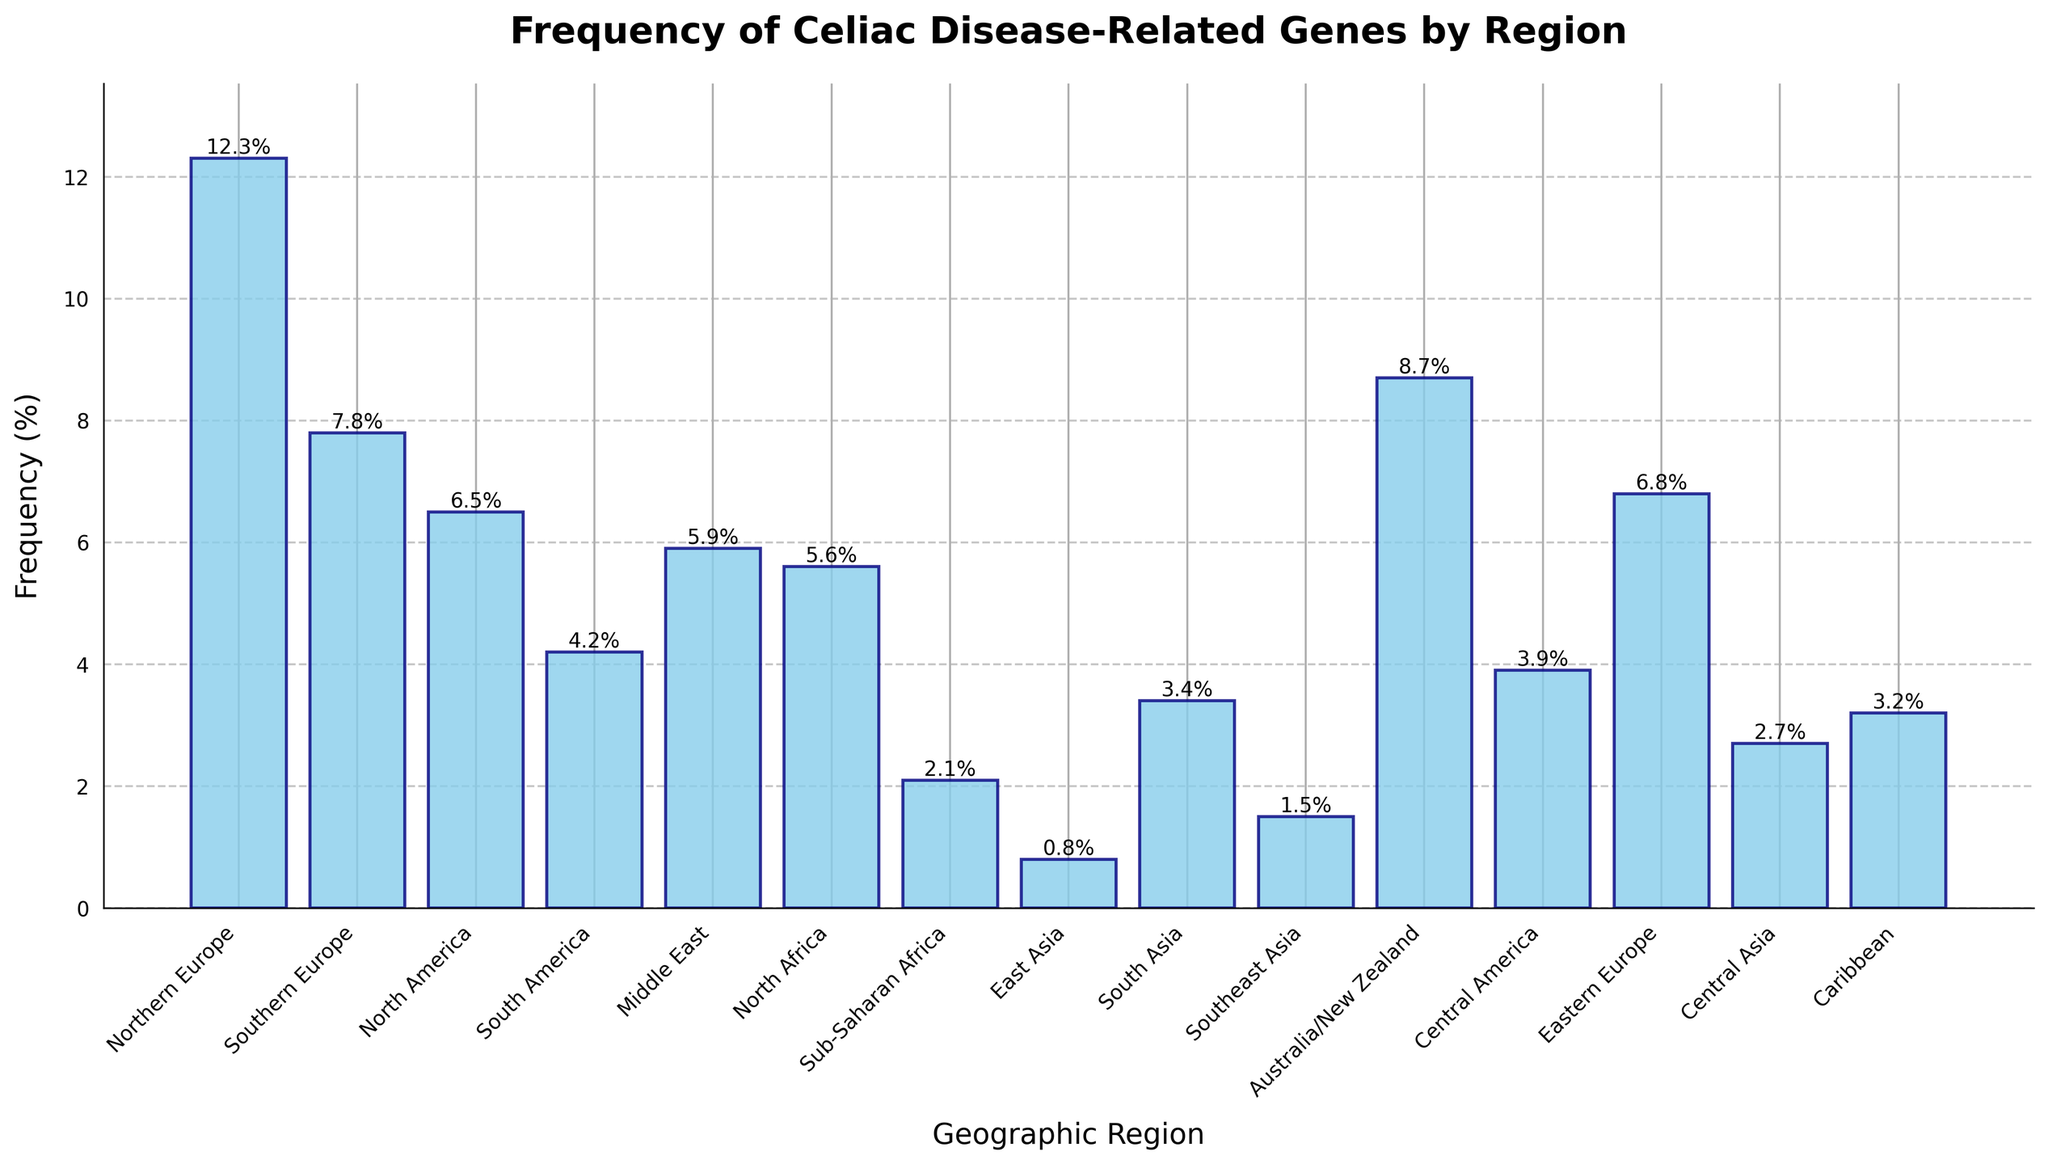Which region shows the highest frequency of celiac disease-related genes? To find this, look at the bar with the greatest height. Northern Europe has the highest bar with a frequency of 12.3%.
Answer: Northern Europe Which region shows the lowest frequency of celiac disease-related genes? To determine the lowest frequency, look at the shortest bar. East Asia has the shortest bar with a frequency of 0.8%.
Answer: East Asia What is the difference in frequency between Northern Europe and East Asia? Find the frequencies for Northern Europe (12.3%) and East Asia (0.8%) and subtract the latter from the former: 12.3 - 0.8 = 11.5%.
Answer: 11.5% How many regions have a frequency of celiac disease-related genes greater than 5%? Identify the bars that exceed the 5% mark: Northern Europe, Southern Europe, North America, Middle East, North Africa, Eastern Europe, Australia/New Zealand. Count them: 7 regions.
Answer: 7 What is the average frequency of celiac disease-related genes for Southern Europe, North America, and South America? Sum the frequencies for Southern Europe (7.8%), North America (6.5%), and South America (4.2%) and divide by 3: (7.8 + 6.5 + 4.2)/3 = 6.2%.
Answer: 6.2% Which region has a frequency closest to that of Southern Europe? Compare the frequency of Southern Europe (7.8%) with other regions. Australia/New Zealand at 8.7% has the closest frequency.
Answer: Australia/New Zealand Compare the frequency of the celiac disease-related genes in Northern Europe with that in Central America. Which one is higher and by how much? Northern Europe has a frequency of 12.3% and Central America has 3.9%. Subtract the latter from the former: 12.3 - 3.9 = 8.4%. Northern Europe is higher.
Answer: Northern Europe, 8.4% What is the combined frequency of celiac disease-related genes for the Middle East and North Africa? Add the frequencies of the Middle East (5.9%) and North Africa (5.6%): 5.9 + 5.6 = 11.5%.
Answer: 11.5% Which regions have a frequency between 3% and 6%? Identify the bars whose heights represent values between 3% and 6%: South America (4.2%), Middle East (5.9%), North Africa (5.6%), Central America (3.9%), Caribbean (3.2%), and South Asia (3.4%). List these regions.
Answer: South America, Middle East, North Africa, Central America, Caribbean, South Asia What is the median frequency of celiac disease-related genes for all regions presented? Organize the frequencies in ascending order: 0.8, 1.5, 2.1, 2.7, 3.2, 3.4, 3.9, 4.2, 5.6, 5.9, 6.5, 6.8, 7.8, 8.7, 12.3. As there are 15 regions, the median is the 8th value in this list, which is 4.2%.
Answer: 4.2% 